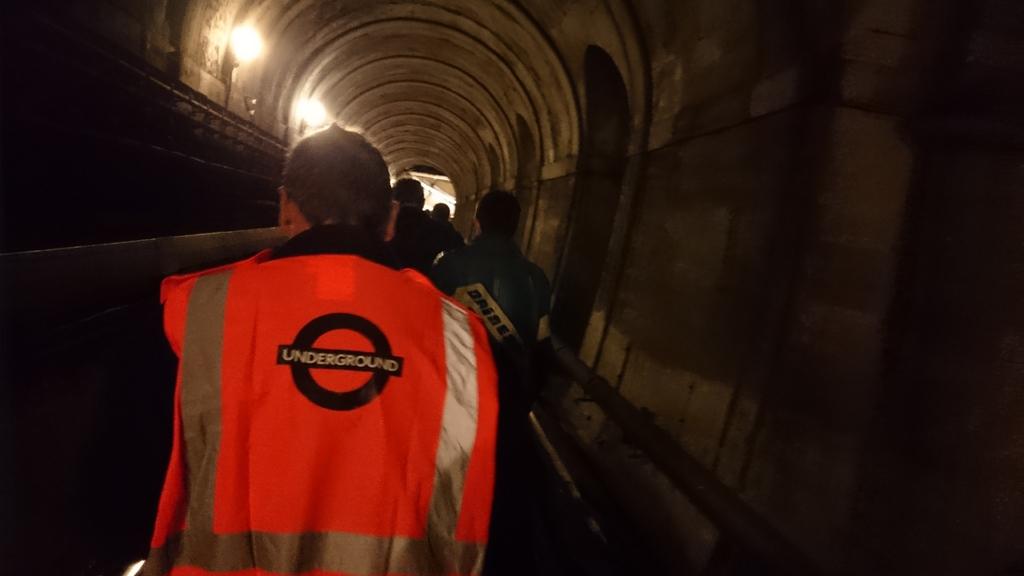Does the logo signify a utility worker?
Offer a very short reply. Yes. 